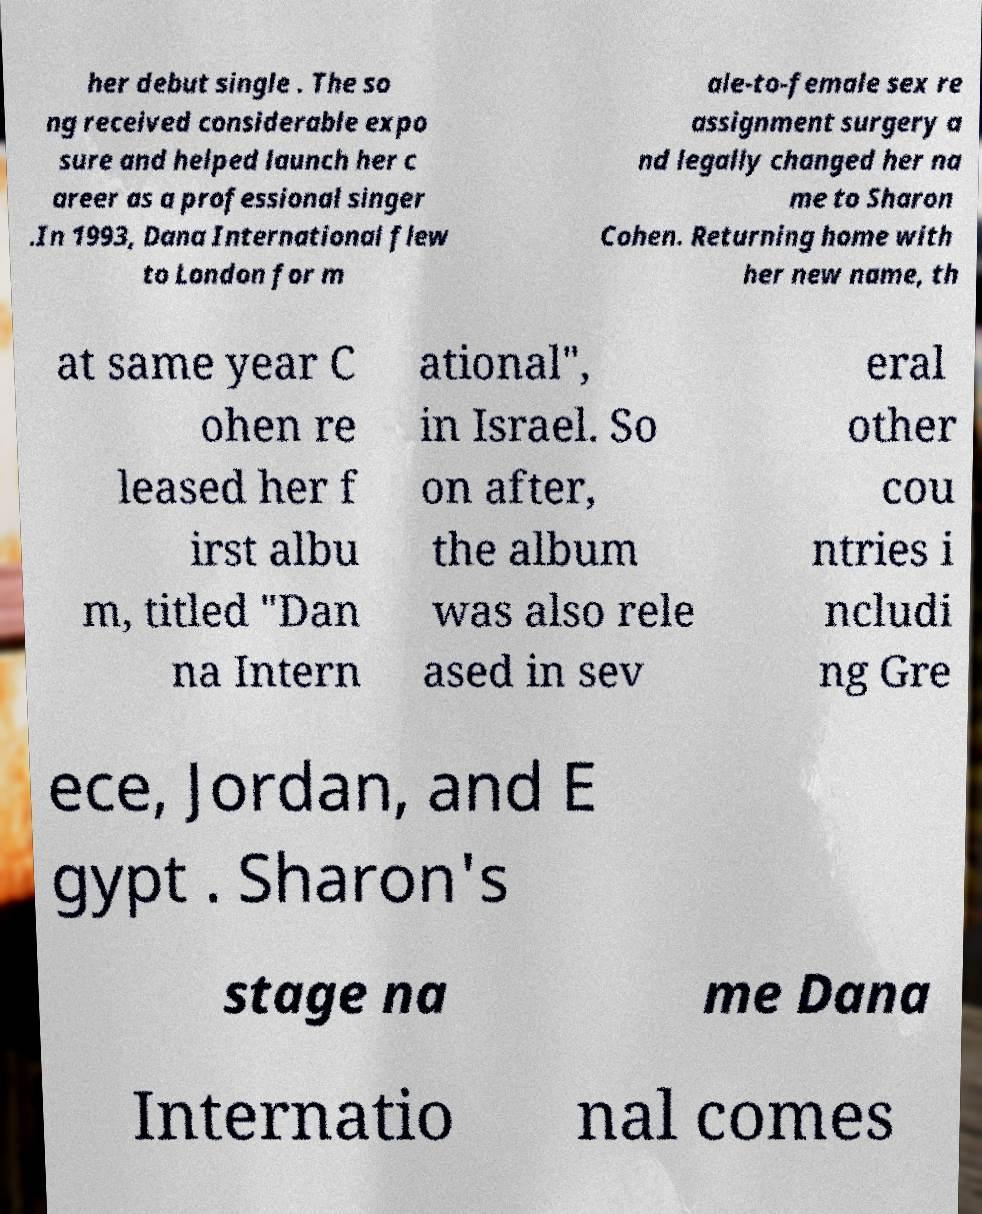Can you read and provide the text displayed in the image?This photo seems to have some interesting text. Can you extract and type it out for me? her debut single . The so ng received considerable expo sure and helped launch her c areer as a professional singer .In 1993, Dana International flew to London for m ale-to-female sex re assignment surgery a nd legally changed her na me to Sharon Cohen. Returning home with her new name, th at same year C ohen re leased her f irst albu m, titled "Dan na Intern ational", in Israel. So on after, the album was also rele ased in sev eral other cou ntries i ncludi ng Gre ece, Jordan, and E gypt . Sharon's stage na me Dana Internatio nal comes 